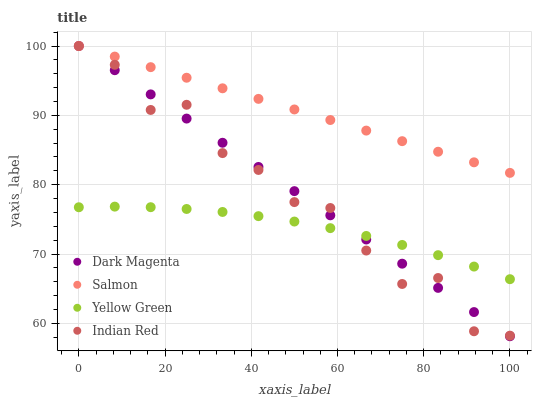Does Yellow Green have the minimum area under the curve?
Answer yes or no. Yes. Does Salmon have the maximum area under the curve?
Answer yes or no. Yes. Does Dark Magenta have the minimum area under the curve?
Answer yes or no. No. Does Dark Magenta have the maximum area under the curve?
Answer yes or no. No. Is Salmon the smoothest?
Answer yes or no. Yes. Is Indian Red the roughest?
Answer yes or no. Yes. Is Dark Magenta the smoothest?
Answer yes or no. No. Is Dark Magenta the roughest?
Answer yes or no. No. Does Dark Magenta have the lowest value?
Answer yes or no. Yes. Does Indian Red have the lowest value?
Answer yes or no. No. Does Indian Red have the highest value?
Answer yes or no. Yes. Does Yellow Green have the highest value?
Answer yes or no. No. Is Yellow Green less than Salmon?
Answer yes or no. Yes. Is Salmon greater than Yellow Green?
Answer yes or no. Yes. Does Dark Magenta intersect Yellow Green?
Answer yes or no. Yes. Is Dark Magenta less than Yellow Green?
Answer yes or no. No. Is Dark Magenta greater than Yellow Green?
Answer yes or no. No. Does Yellow Green intersect Salmon?
Answer yes or no. No. 